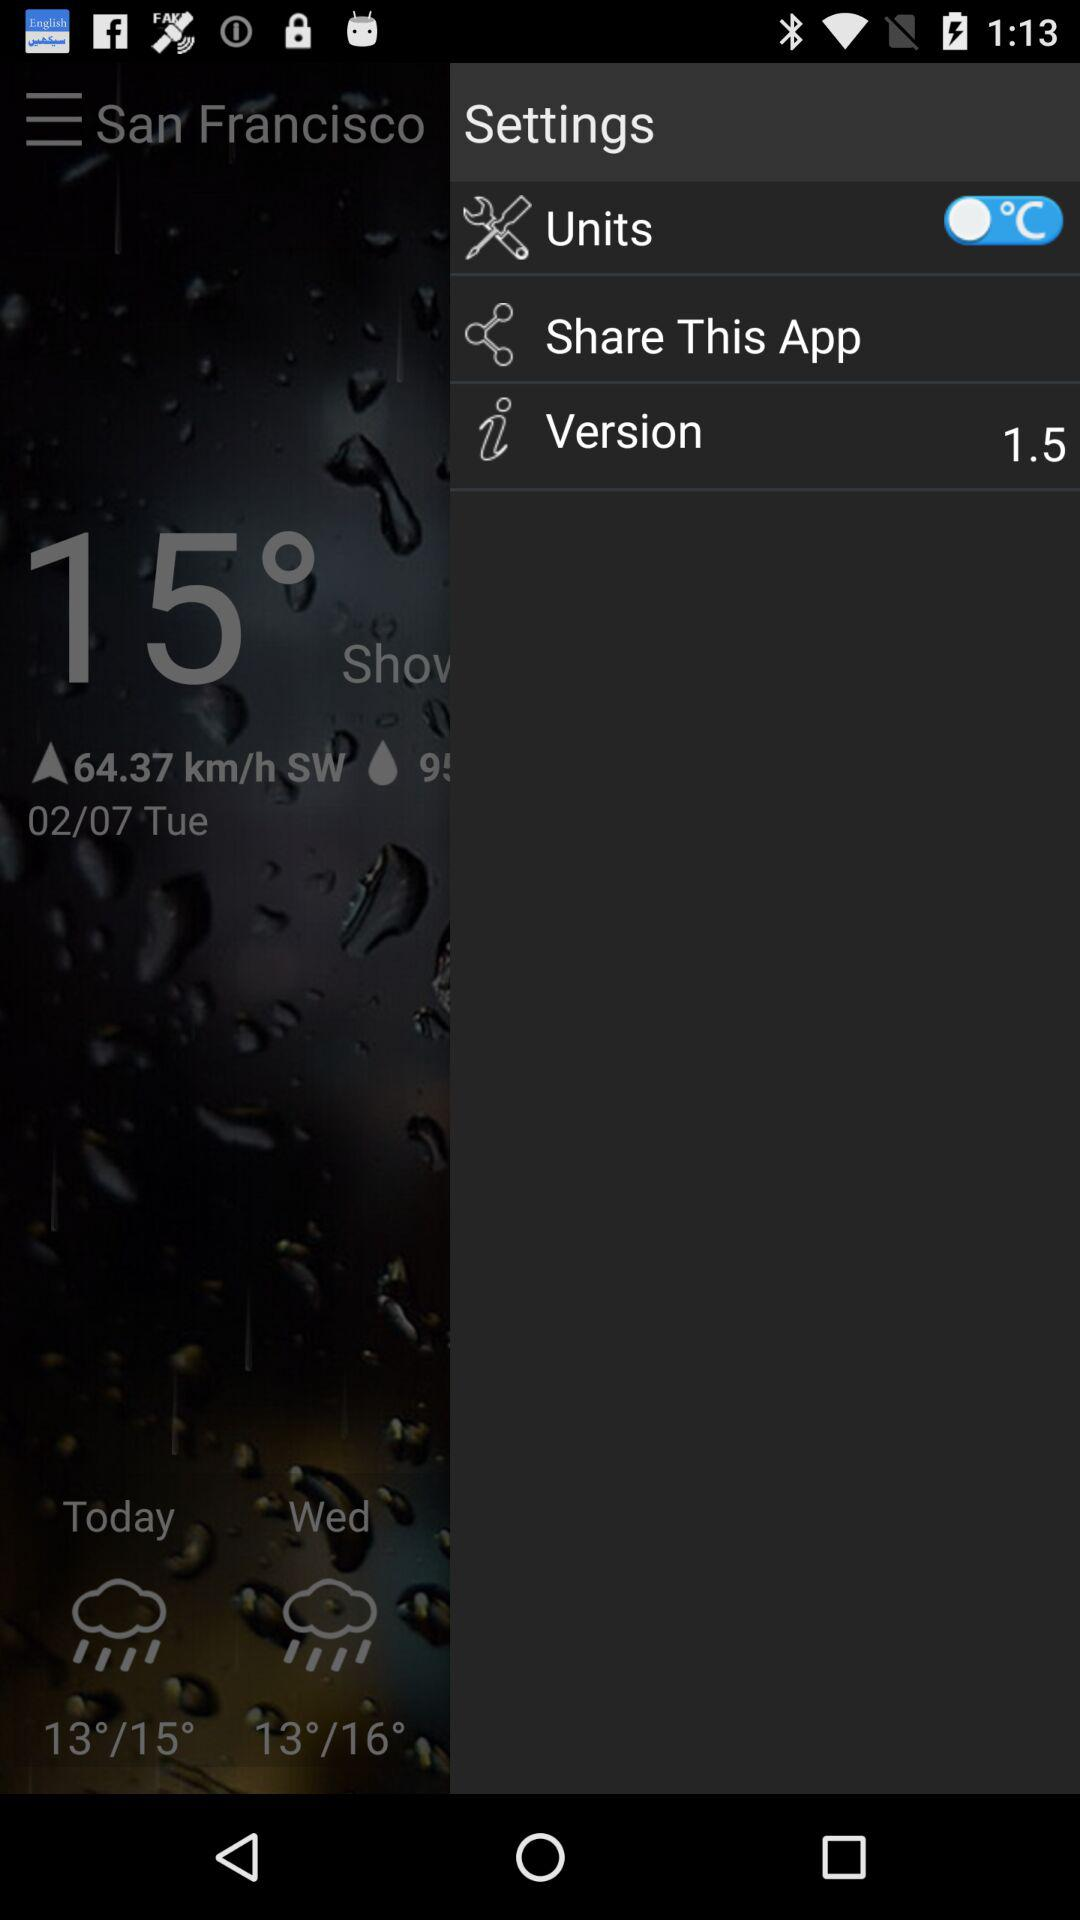What's the status of "Units"? The status of units is "off". 